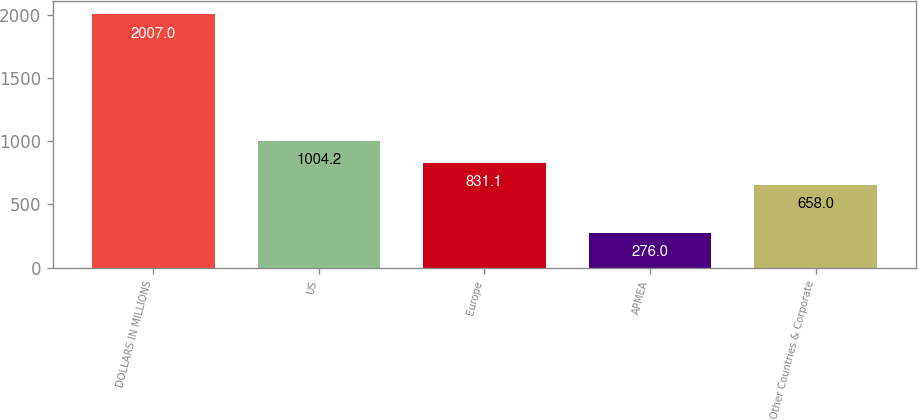Convert chart. <chart><loc_0><loc_0><loc_500><loc_500><bar_chart><fcel>DOLLARS IN MILLIONS<fcel>US<fcel>Europe<fcel>APMEA<fcel>Other Countries & Corporate<nl><fcel>2007<fcel>1004.2<fcel>831.1<fcel>276<fcel>658<nl></chart> 